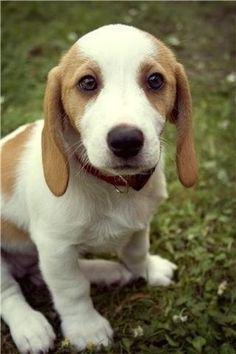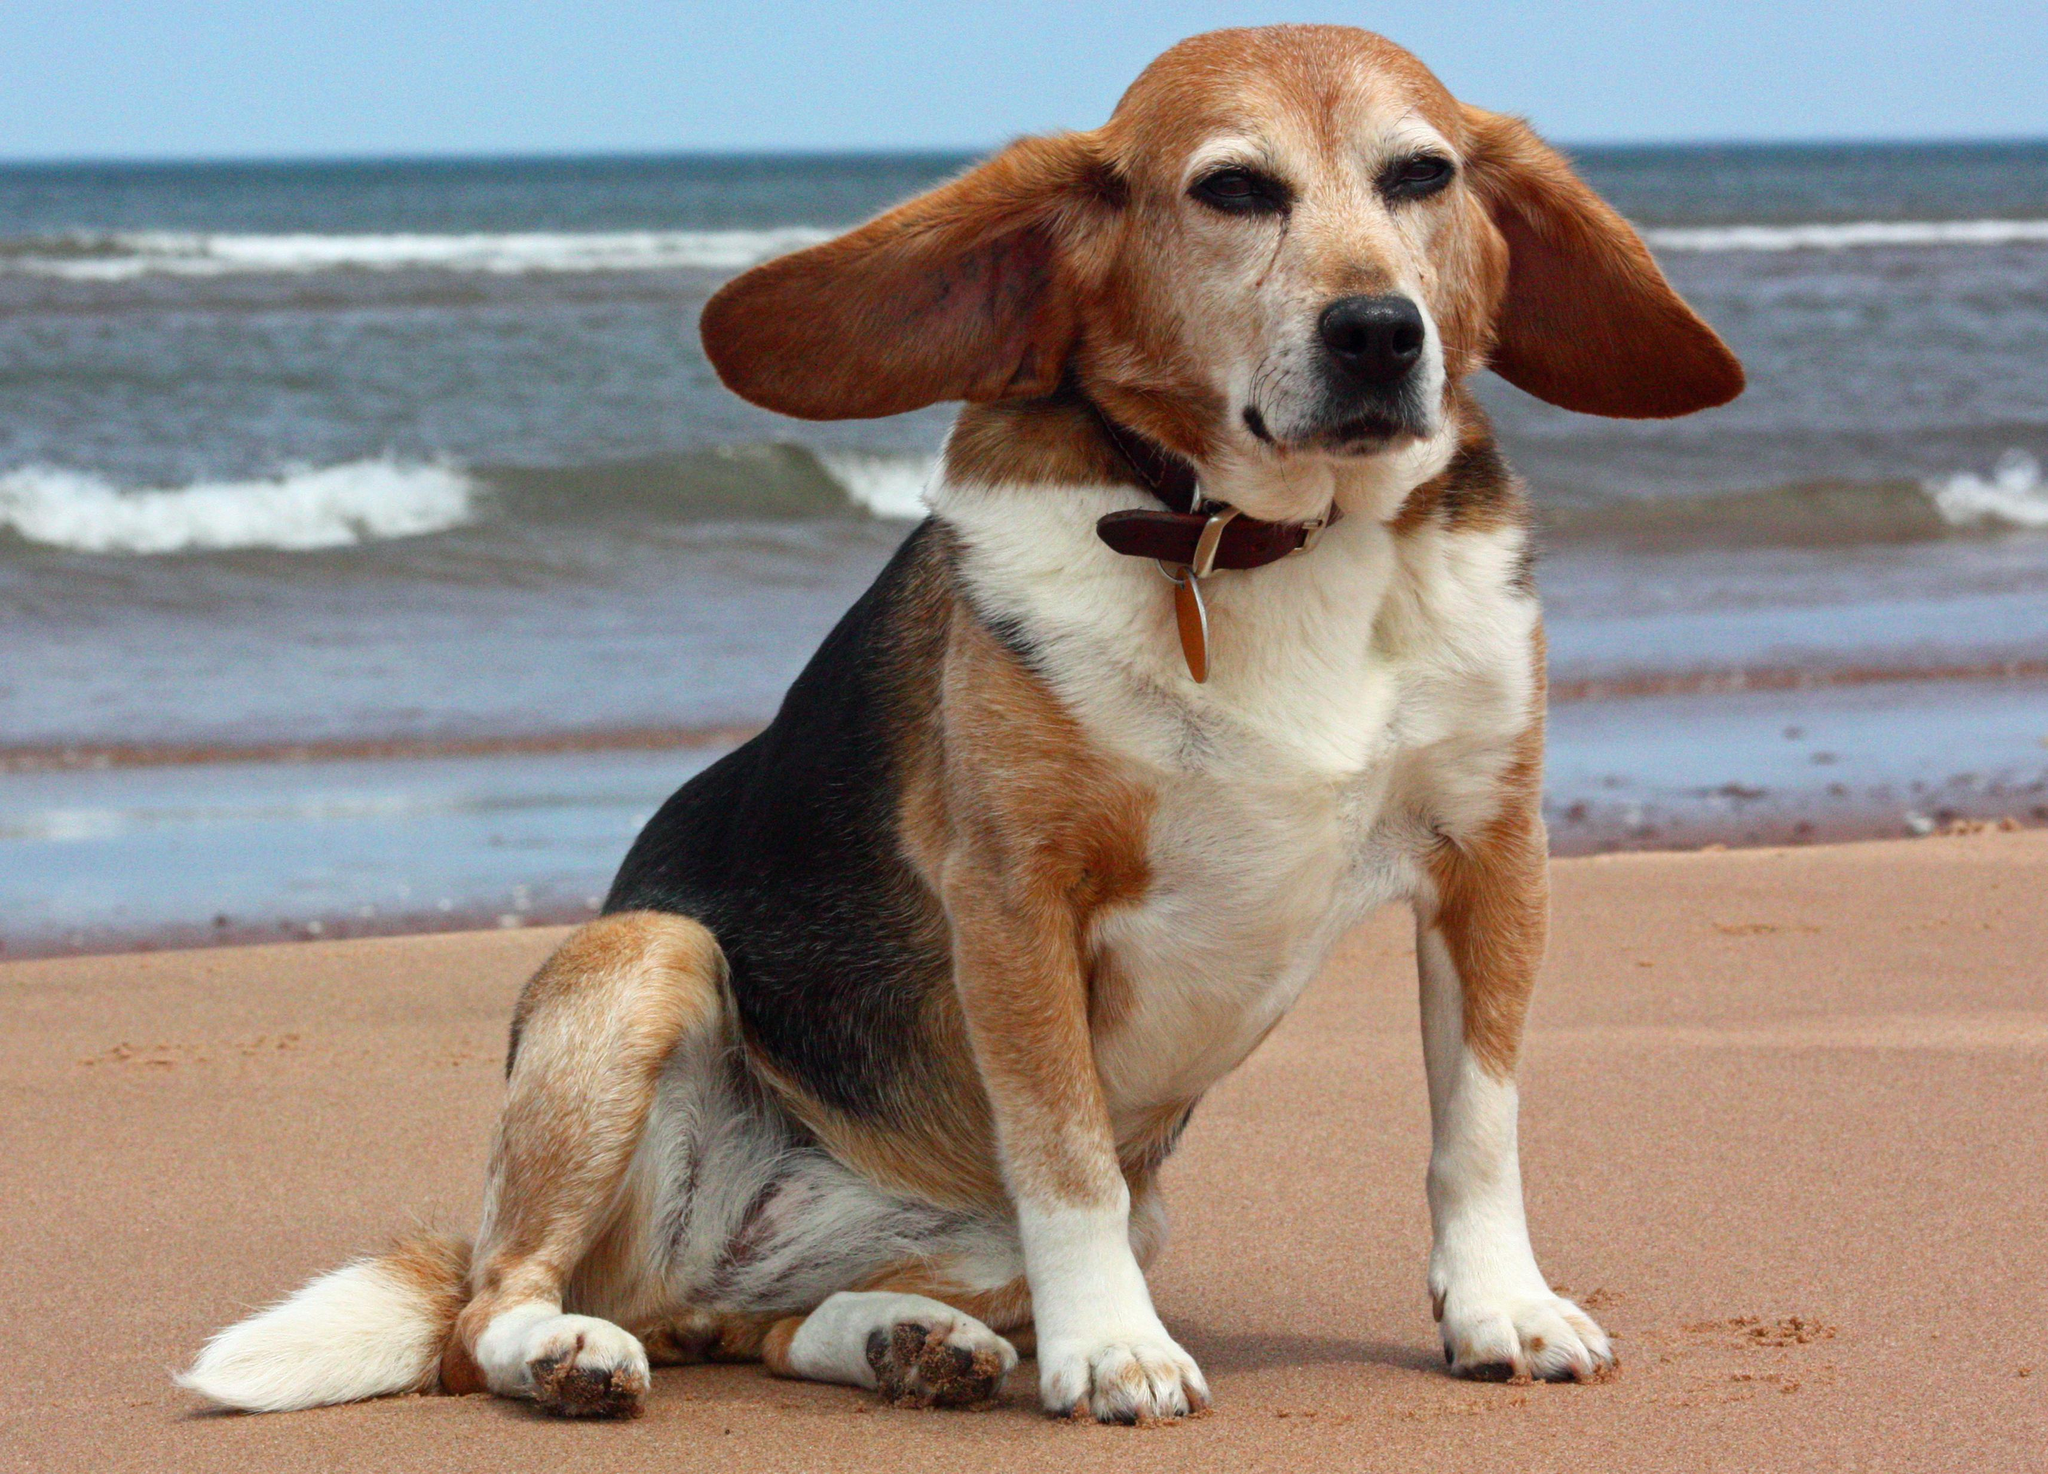The first image is the image on the left, the second image is the image on the right. For the images displayed, is the sentence "There is an image of a tan and white puppy sitting on grass." factually correct? Answer yes or no. Yes. 